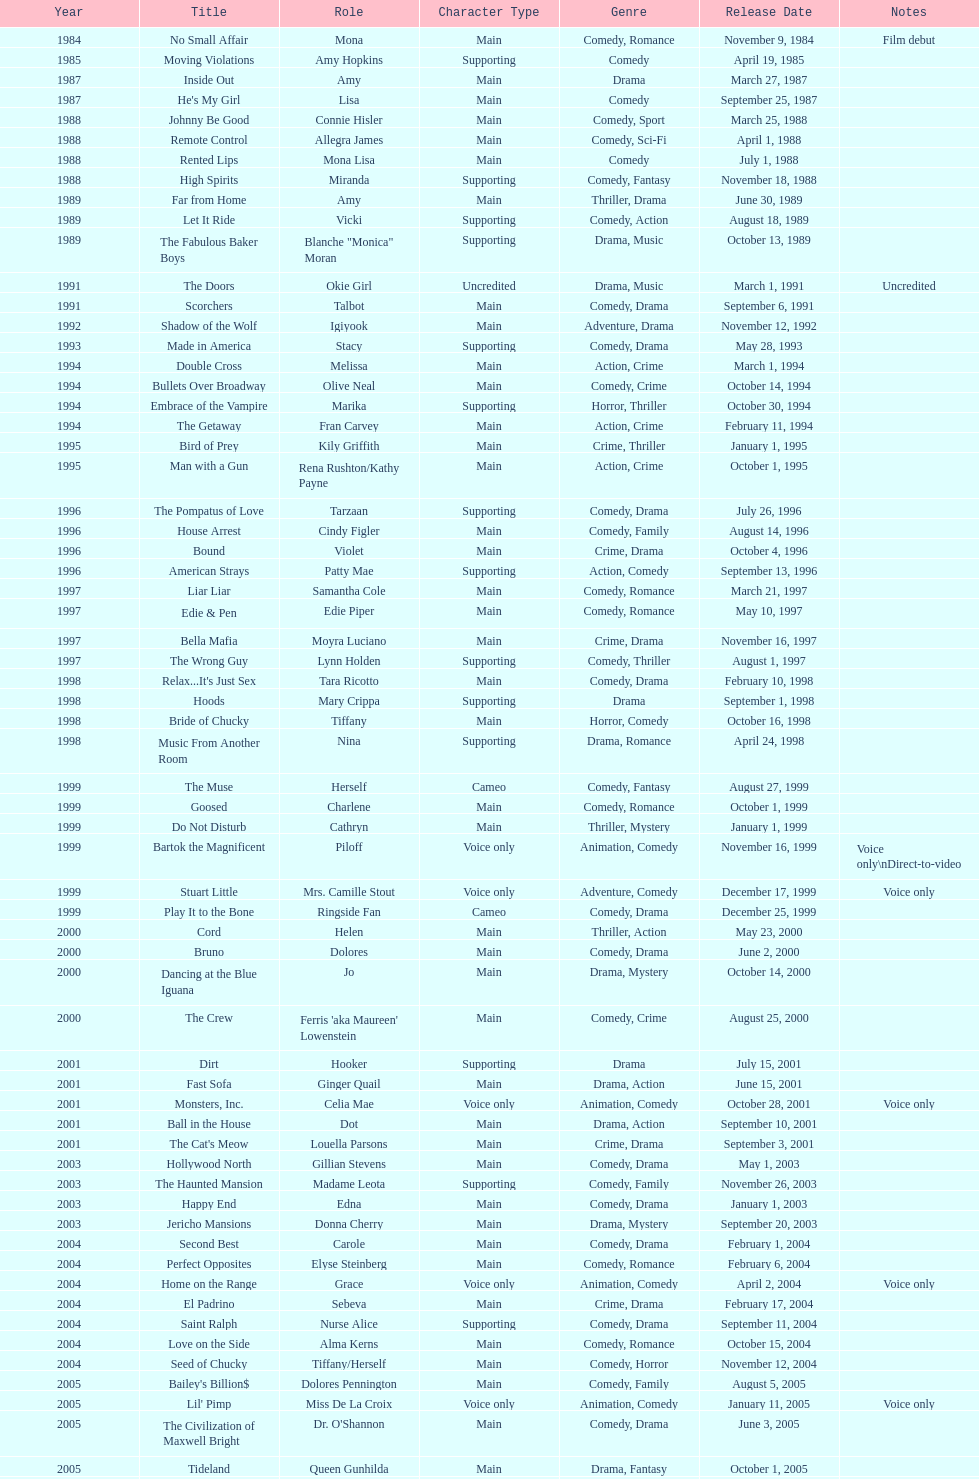Which movie was also a film debut? No Small Affair. 